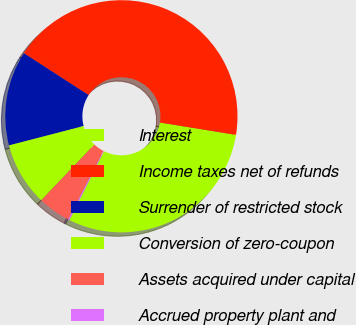<chart> <loc_0><loc_0><loc_500><loc_500><pie_chart><fcel>Interest<fcel>Income taxes net of refunds<fcel>Surrender of restricted stock<fcel>Conversion of zero-coupon<fcel>Assets acquired under capital<fcel>Accrued property plant and<nl><fcel>29.84%<fcel>43.43%<fcel>13.17%<fcel>8.85%<fcel>4.52%<fcel>0.2%<nl></chart> 